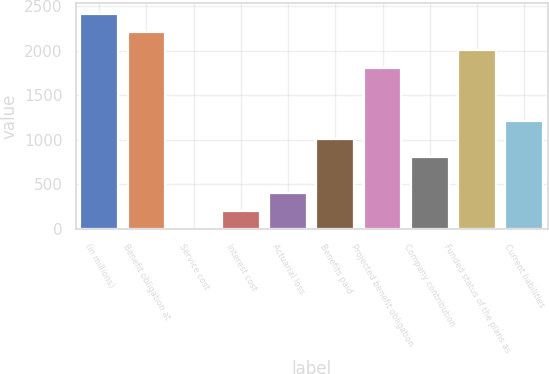<chart> <loc_0><loc_0><loc_500><loc_500><bar_chart><fcel>(in millions)<fcel>Benefit obligation at<fcel>Service cost<fcel>Interest cost<fcel>Actuarial loss<fcel>Benefits paid<fcel>Projected benefit obligation<fcel>Company contribution<fcel>Funded status of the plans as<fcel>Current liabilities<nl><fcel>2414.34<fcel>2213.17<fcel>0.3<fcel>201.47<fcel>402.64<fcel>1006.15<fcel>1810.83<fcel>804.98<fcel>2012<fcel>1207.32<nl></chart> 